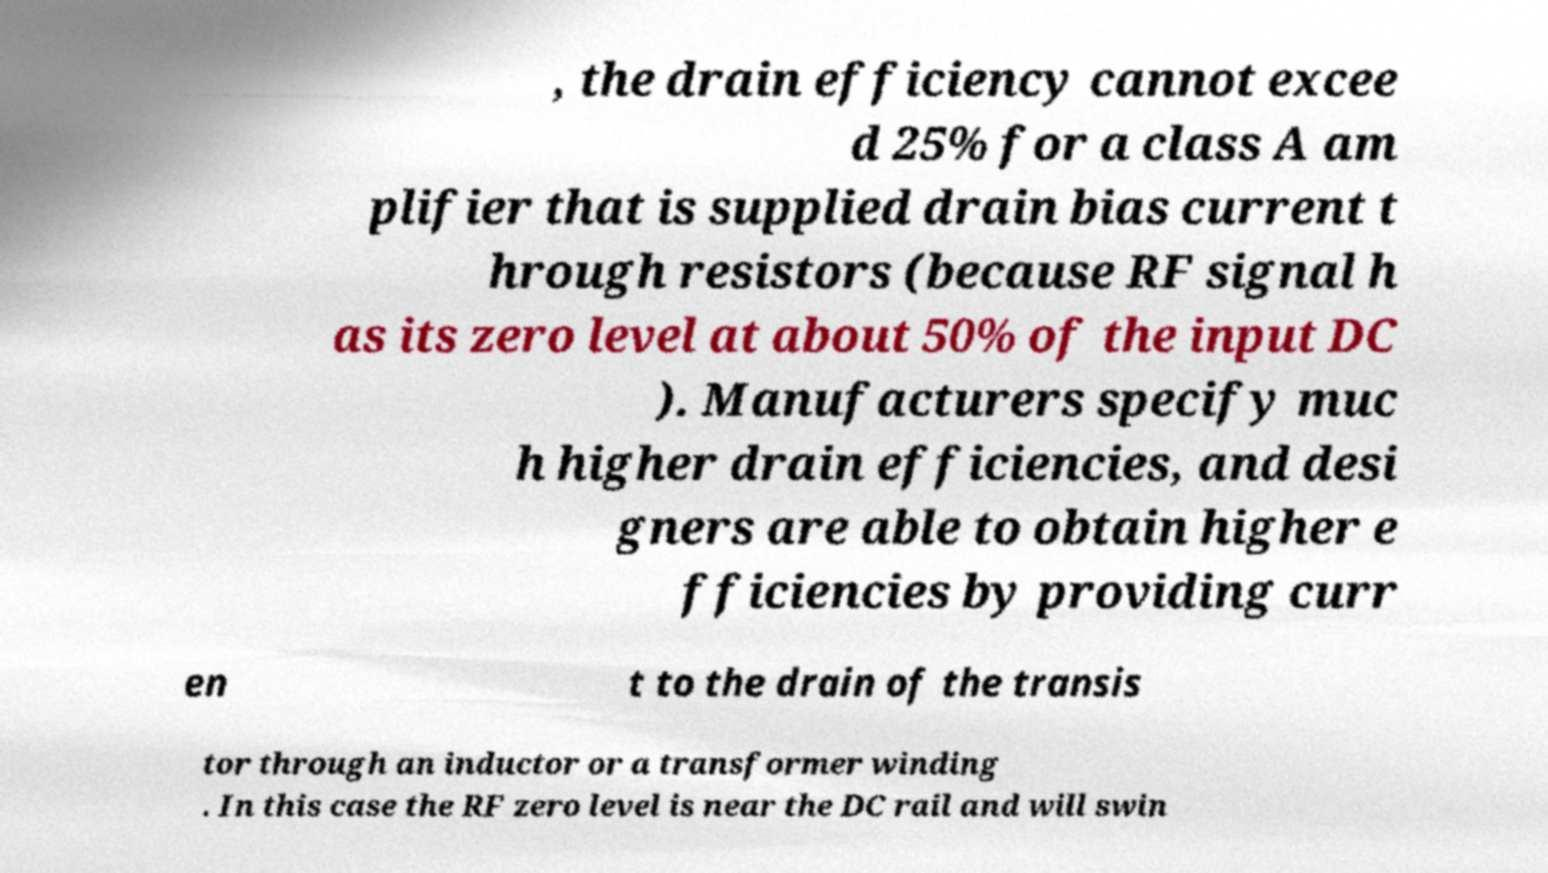Could you extract and type out the text from this image? , the drain efficiency cannot excee d 25% for a class A am plifier that is supplied drain bias current t hrough resistors (because RF signal h as its zero level at about 50% of the input DC ). Manufacturers specify muc h higher drain efficiencies, and desi gners are able to obtain higher e fficiencies by providing curr en t to the drain of the transis tor through an inductor or a transformer winding . In this case the RF zero level is near the DC rail and will swin 